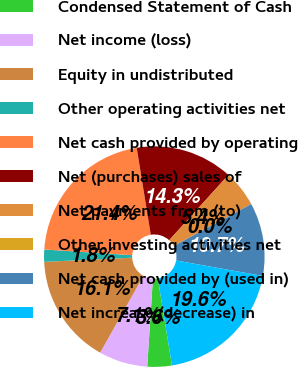Convert chart to OTSL. <chart><loc_0><loc_0><loc_500><loc_500><pie_chart><fcel>Condensed Statement of Cash<fcel>Net income (loss)<fcel>Equity in undistributed<fcel>Other operating activities net<fcel>Net cash provided by operating<fcel>Net (purchases) sales of<fcel>Net payments from (to)<fcel>Other investing activities net<fcel>Net cash provided by (used in)<fcel>Net increase (decrease) in<nl><fcel>3.58%<fcel>7.15%<fcel>16.07%<fcel>1.79%<fcel>21.42%<fcel>14.28%<fcel>5.36%<fcel>0.01%<fcel>10.71%<fcel>19.64%<nl></chart> 